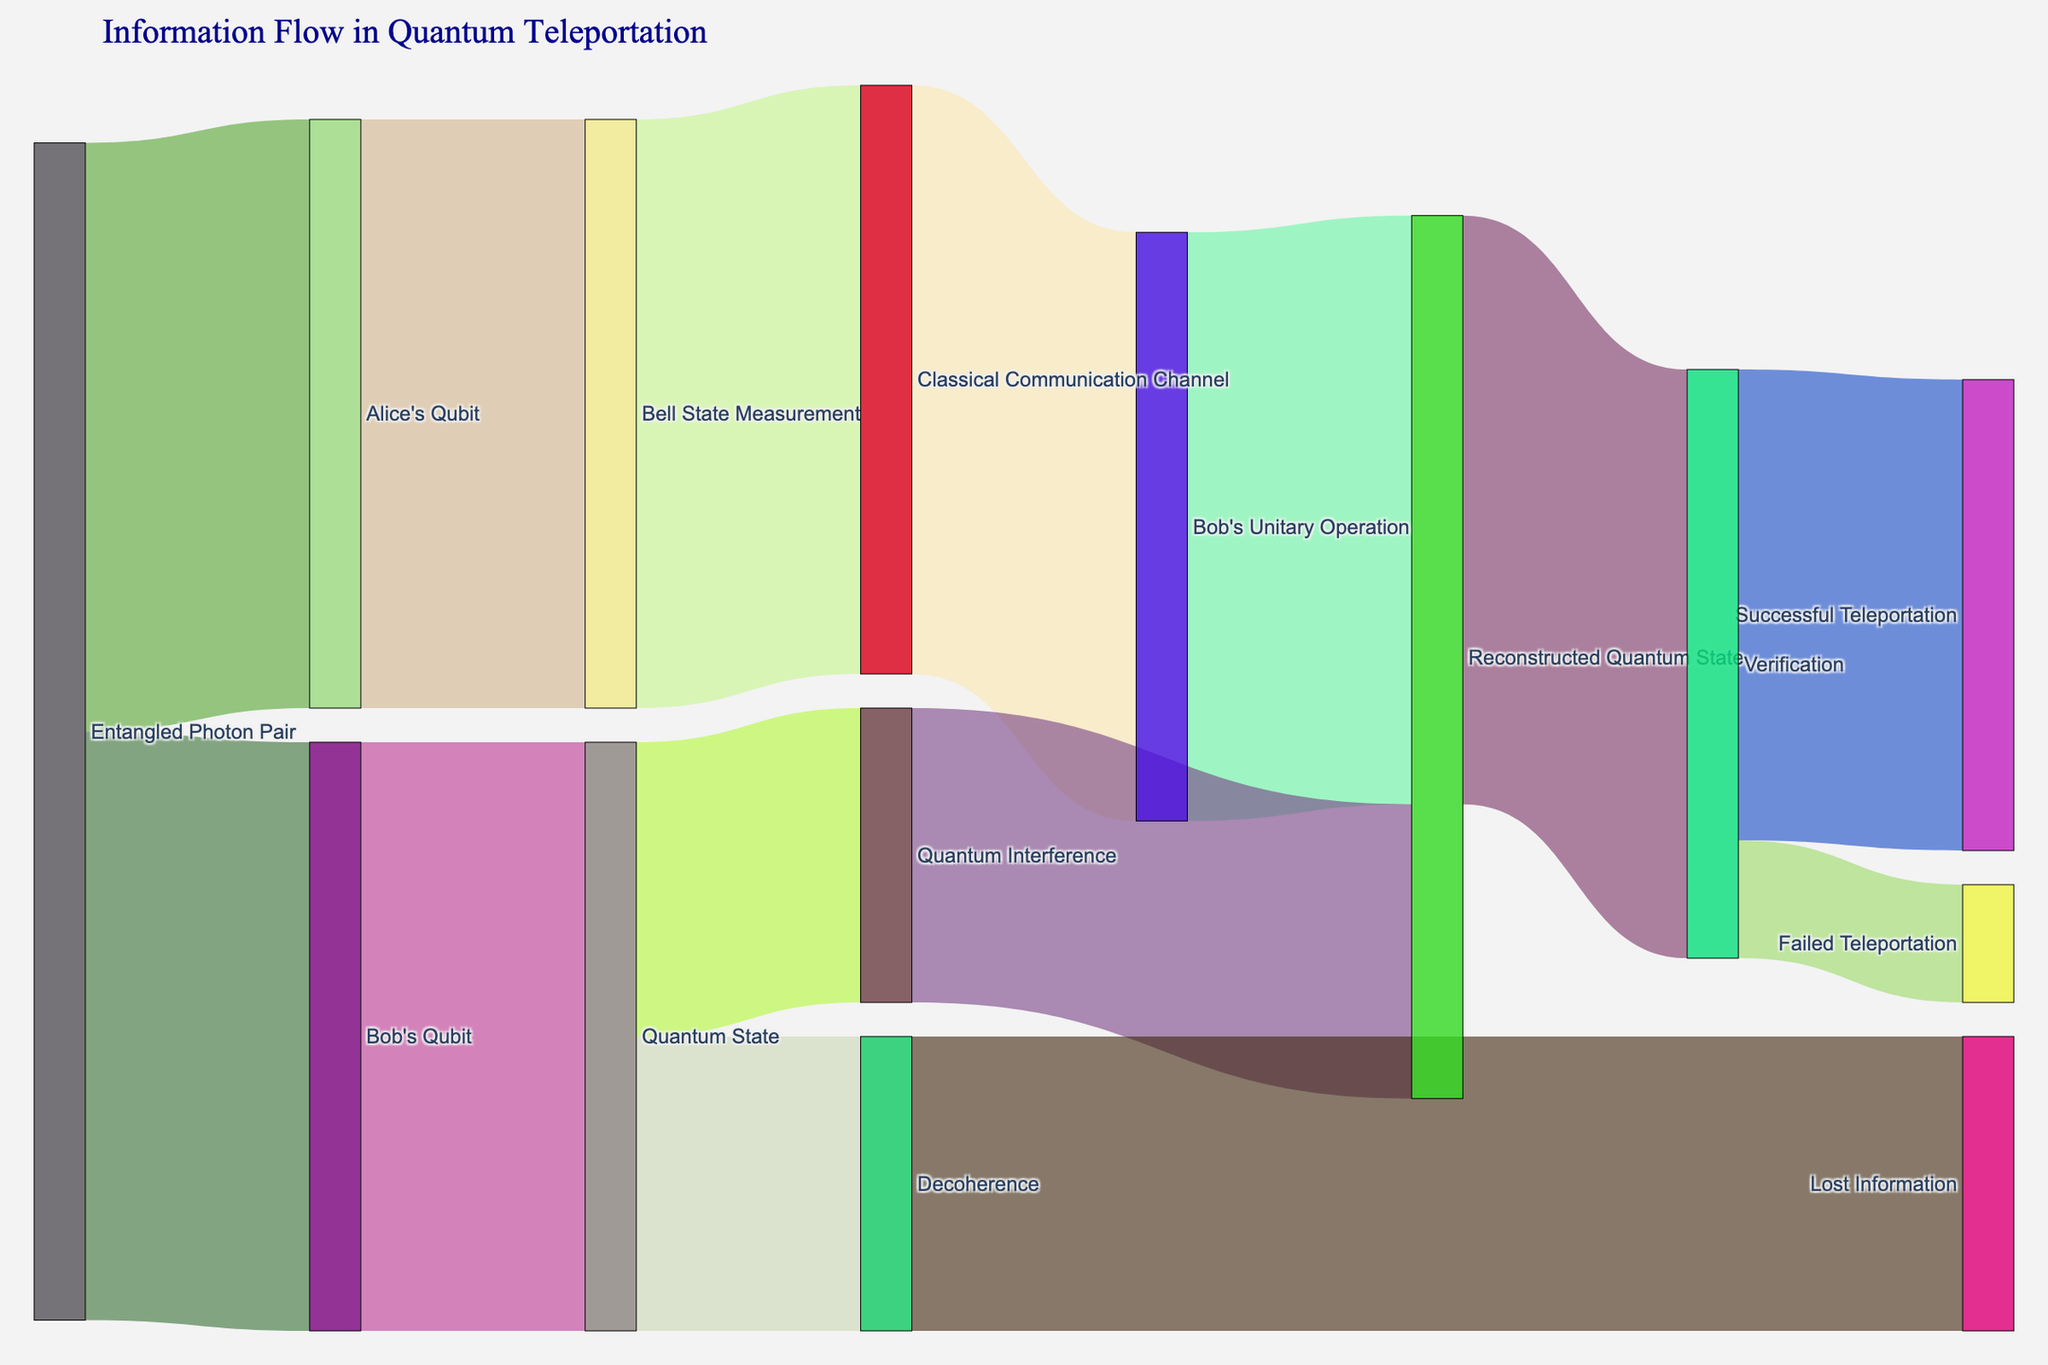What is the title of the Sankey diagram? The title can usually be found at the top of the figure. Here, the title is "Information Flow in Quantum Teleportation."
Answer: Information Flow in Quantum Teleportation How many different stages are involved in the information flow for quantum teleportation? Count the unique stages mentioned in the nodes. The stages are: Entangled Photon Pair, Alice's Qubit, Bob's Qubit, Bell State Measurement, Classical Communication Channel, Bob's Unitary Operation, Reconstructed Quantum State, Quantum State, Quantum Interference, Decoherence, Lost Information, Verification, Successful Teleportation, Failed Teleportation.
Answer: 14 What is the initial source of the information flow? The initial source can be identified by looking at which node has only outbound links. This node is the starting point: Entangled Photon Pair.
Answer: Entangled Photon Pair How many units of information are lost due to decoherence? The diagram shows a flow from 'Decoherence' to 'Lost Information'. The value of this link represents the lost units: 50 units.
Answer: 50 units What are the two possible outcomes of the verification stage in the teleportation process? The outputs from 'Verification' node can be identified by examining its outbound links. These are labeled 'Successful Teleportation' and 'Failed Teleportation'.
Answer: Successful Teleportation, Failed Teleportation What is the combined value of the paths leading to the reconstructed quantum state? To find the combined value, sum the values of all paths leading to the 'Reconstructed Quantum State' node: from 'Bob's Unitary Operation' (100 units) and 'Quantum Interference' (50 units), so 100 + 50 = 150 units.
Answer: 150 units What percentage of the total verification measurements resulted in successful teleportation? The total verification measurements is the sum of successful and failed teleportations: 80 (successful) + 20 (failed) = 100. The percentage for successful teleportation is (80 / 100) * 100 = 80%.
Answer: 80% After the Bell State Measurement, what is the next step in the information flow? The next step can be determined by the outbound link from 'Bell State Measurement'. The next node is 'Classical Communication Channel'.
Answer: Classical Communication Channel How does the amount of information remaining in the quantum state compare to the amount lost to decoherence? The incoming links to both 'Quantum State' and 'Decoherence' need to be analyzed. Both links from 'Quantum State' to 'Quantum Interference' and to 'Decoherence' result in 50 units. Thus, both retain 50 units each.
Answer: Equal Which node directly contributes to the verification stage? To determine the direct contributor to 'Verification', trace back its inbound flow links. The sender node is 'Reconstructed Quantum State'.
Answer: Reconstructed Quantum State 